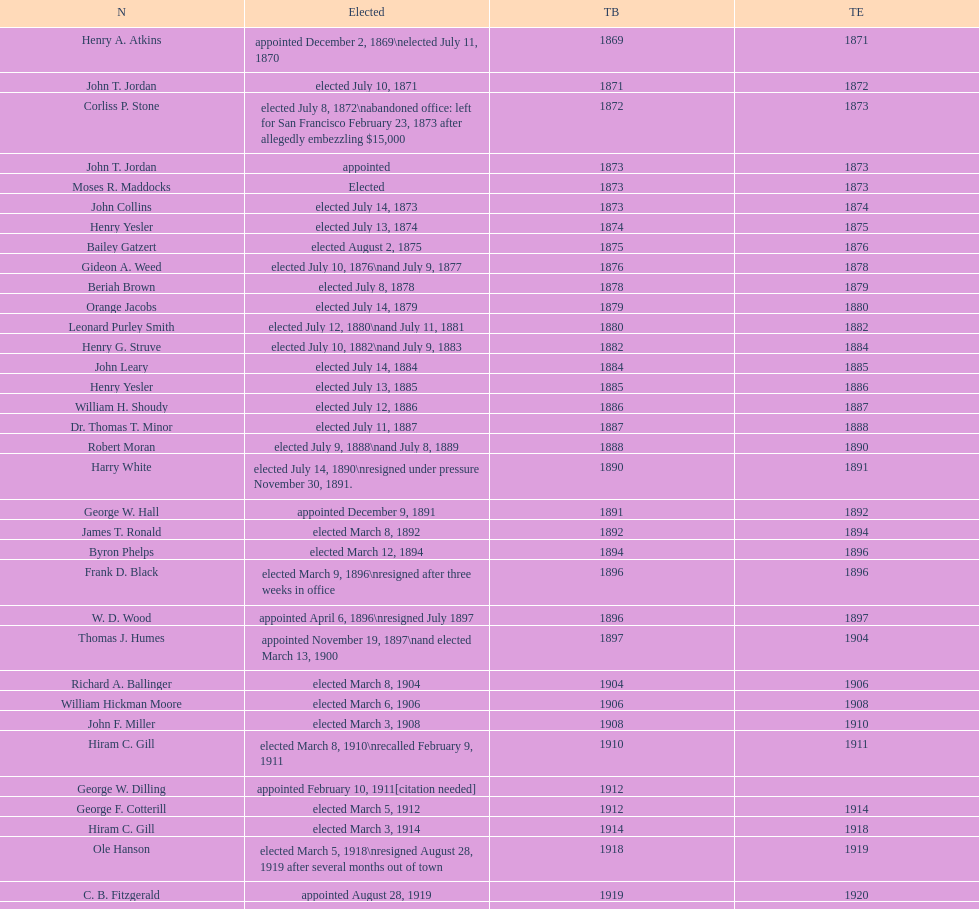Who was the first mayor in the 1900's? Richard A. Ballinger. 